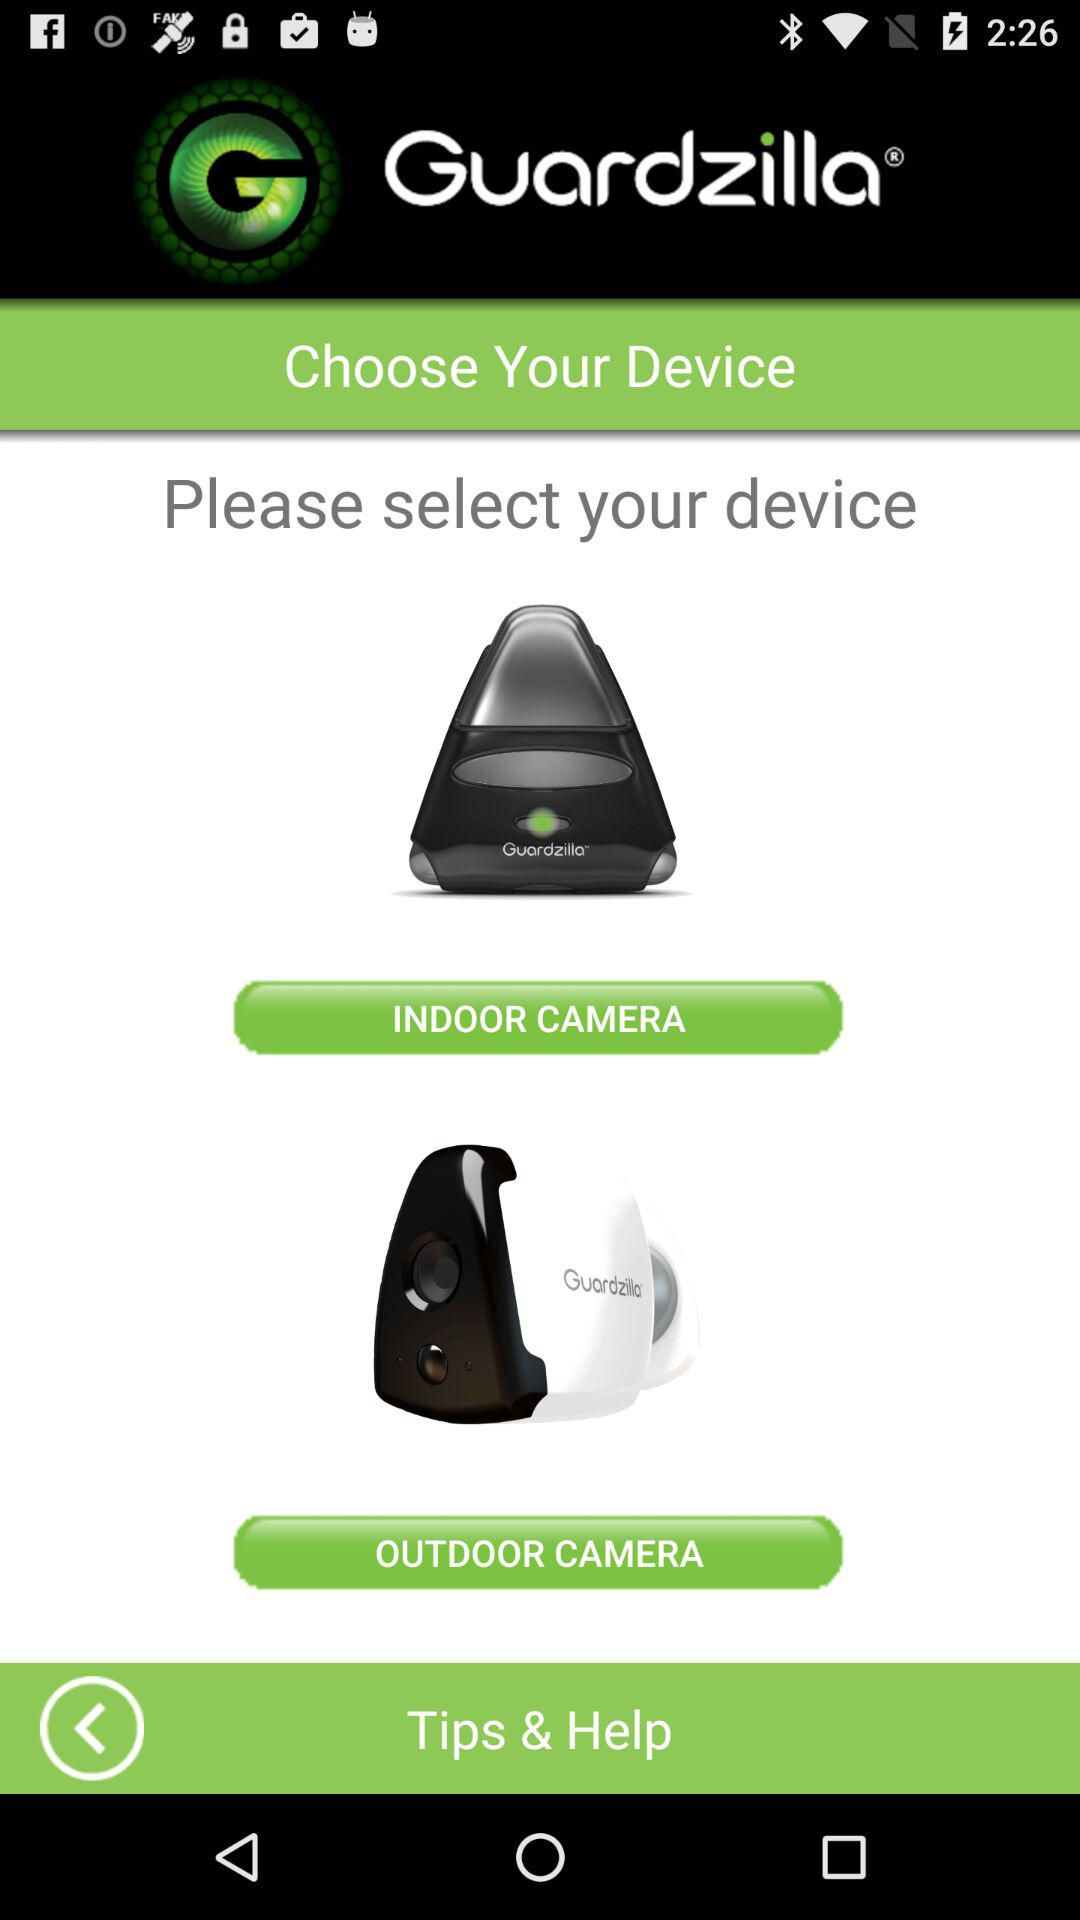How many devices are there to choose from?
Answer the question using a single word or phrase. 2 